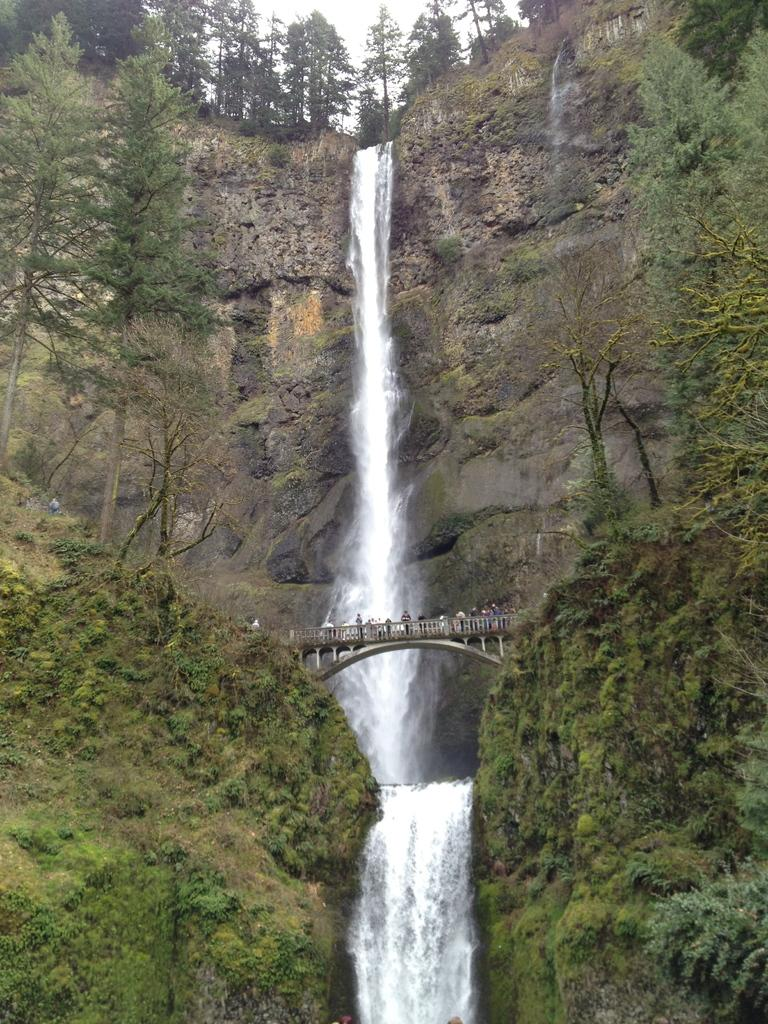What are the people in the image doing? The people in the image are on a bridge. What can be seen in the background of the image? There are trees, hills, and a waterfall visible in the background of the image. What type of haircut is the waterfall giving to the trees in the image? There is no haircut being given in the image, as the waterfall is a natural feature and not a person or object capable of providing a haircut. 